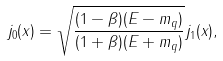<formula> <loc_0><loc_0><loc_500><loc_500>j _ { 0 } ( x ) = \sqrt { \frac { ( 1 - \beta ) ( E - m _ { q } ) } { ( 1 + \beta ) ( E + m _ { q } ) } } j _ { 1 } ( x ) ,</formula> 